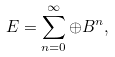<formula> <loc_0><loc_0><loc_500><loc_500>E = \sum ^ { \infty } _ { n = 0 } \oplus B ^ { n } ,</formula> 